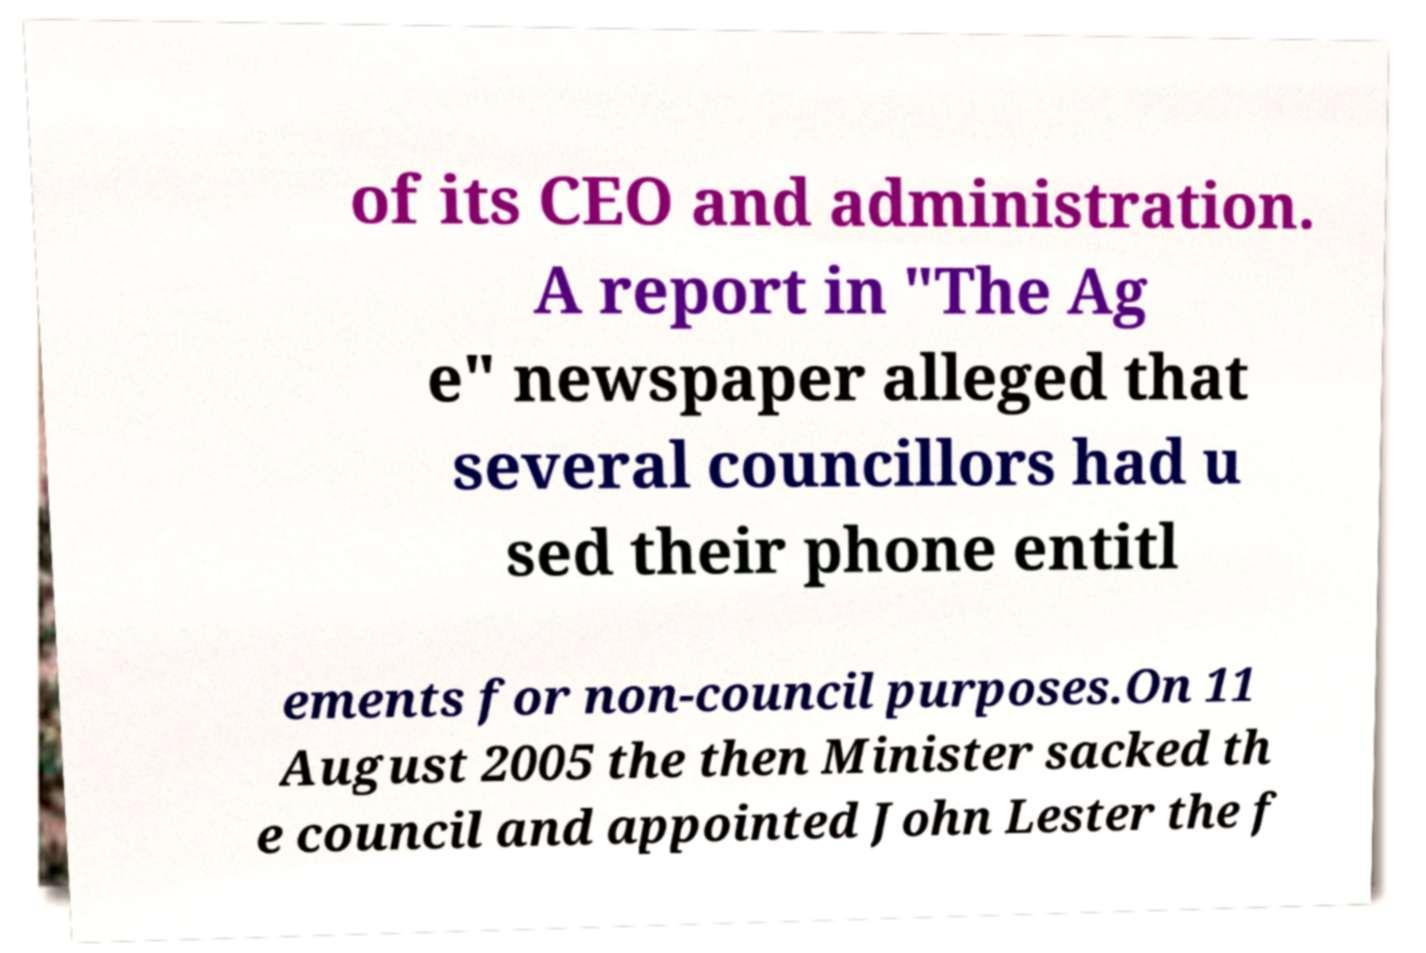Could you extract and type out the text from this image? of its CEO and administration. A report in "The Ag e" newspaper alleged that several councillors had u sed their phone entitl ements for non-council purposes.On 11 August 2005 the then Minister sacked th e council and appointed John Lester the f 